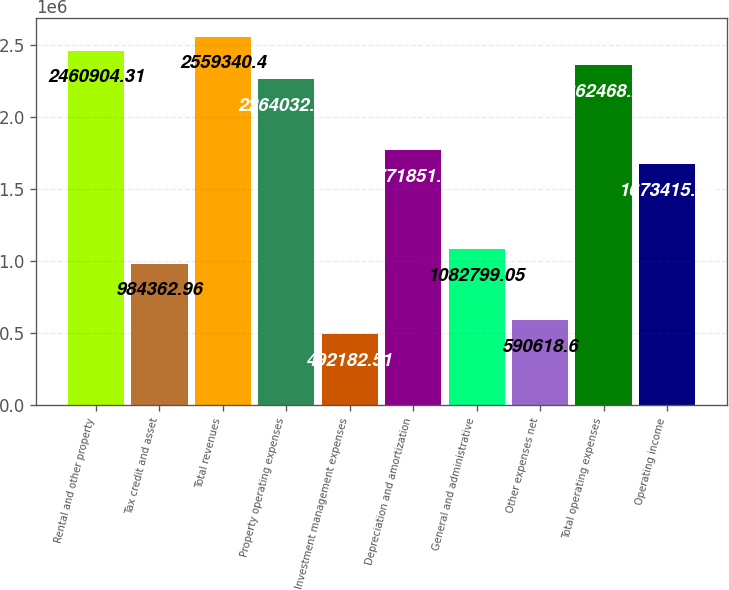Convert chart. <chart><loc_0><loc_0><loc_500><loc_500><bar_chart><fcel>Rental and other property<fcel>Tax credit and asset<fcel>Total revenues<fcel>Property operating expenses<fcel>Investment management expenses<fcel>Depreciation and amortization<fcel>General and administrative<fcel>Other expenses net<fcel>Total operating expenses<fcel>Operating income<nl><fcel>2.4609e+06<fcel>984363<fcel>2.55934e+06<fcel>2.26403e+06<fcel>492183<fcel>1.77185e+06<fcel>1.0828e+06<fcel>590619<fcel>2.36247e+06<fcel>1.67342e+06<nl></chart> 